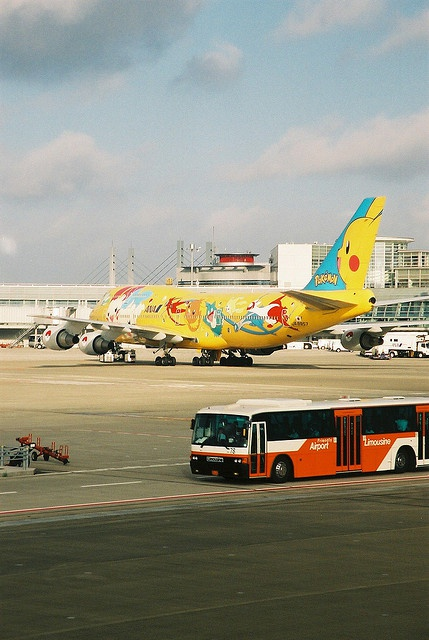Describe the objects in this image and their specific colors. I can see airplane in lightgray, khaki, gold, and beige tones, bus in lightgray, black, red, beige, and tan tones, and truck in lightgray, ivory, black, darkgray, and gray tones in this image. 